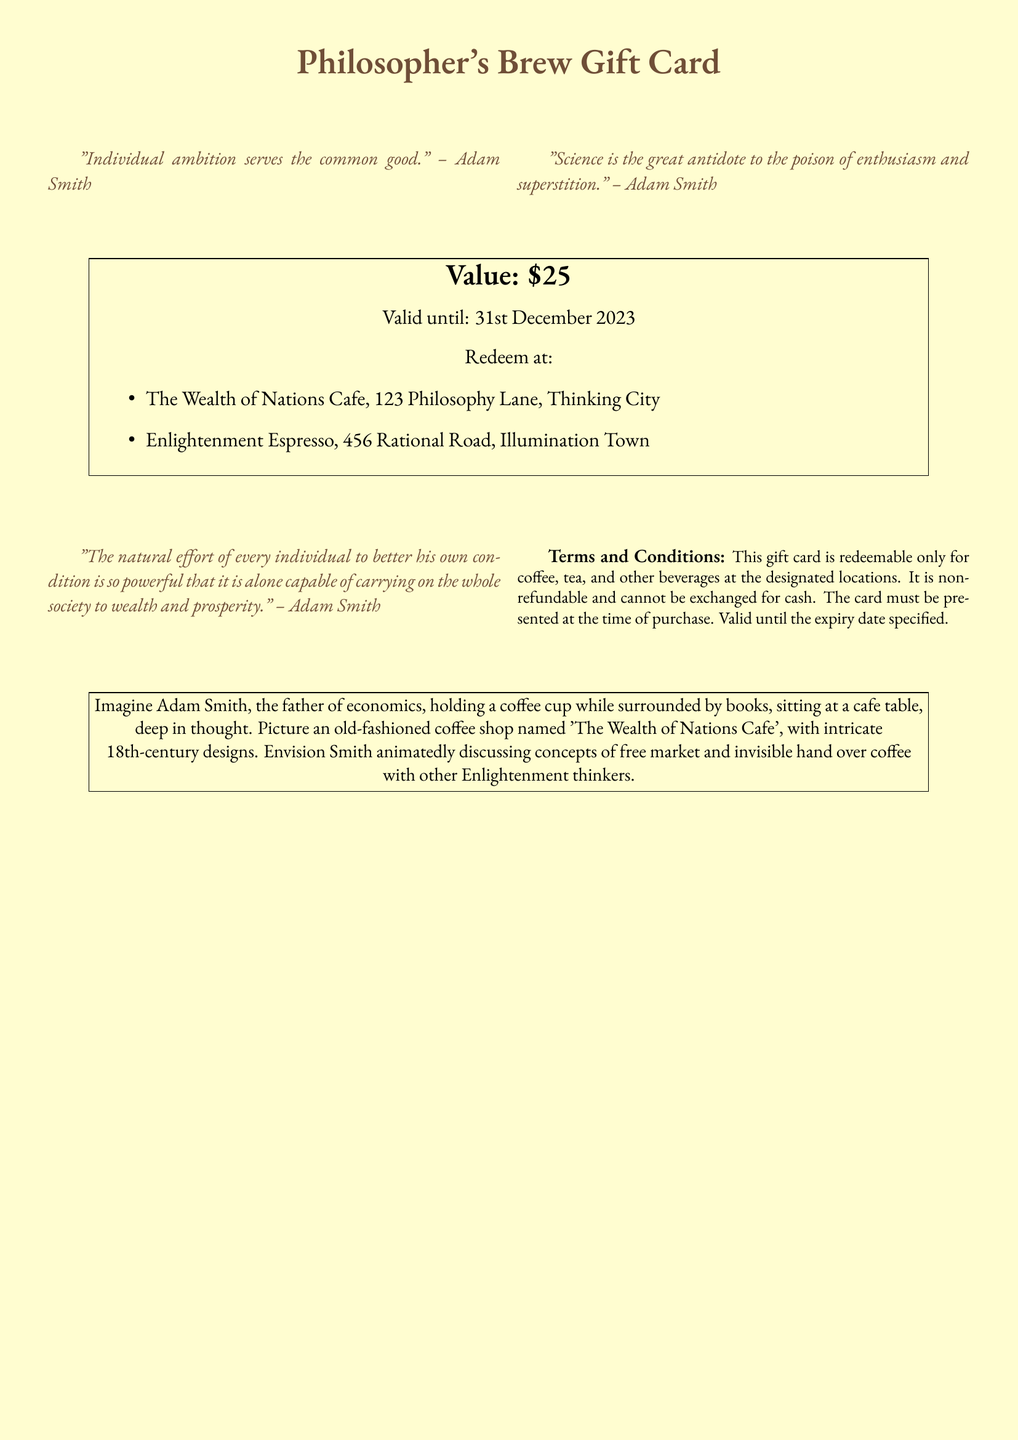What is the value of the gift card? The document explicitly states the value of the gift card is $25.
Answer: $25 What is the expiry date of the card? The document indicates that the card is valid until 31st December 2023.
Answer: 31st December 2023 Where can the gift card be redeemed? The document lists two locations where the gift card can be redeemed: The Wealth of Nations Cafe and Enlightenment Espresso.
Answer: The Wealth of Nations Cafe, Enlightenment Espresso Who is quoted in the phrases on the card? The document includes quotes attributed to Adam Smith.
Answer: Adam Smith What is the document type? The primary purpose of the document and its content classify it as a gift card.
Answer: Gift card What is the main theme depicted in the illustrations? The illustrations center around concepts related to Adam Smith and his philosophical ideas.
Answer: Adam Smith-themed illustrations Is the gift card refundable? The document specifies that the gift card is non-refundable.
Answer: Non-refundable What type of beverages can the gift card be used for? The document states that the gift card can be redeemed for coffee, tea, and other beverages.
Answer: Coffee, tea, and other beverages 